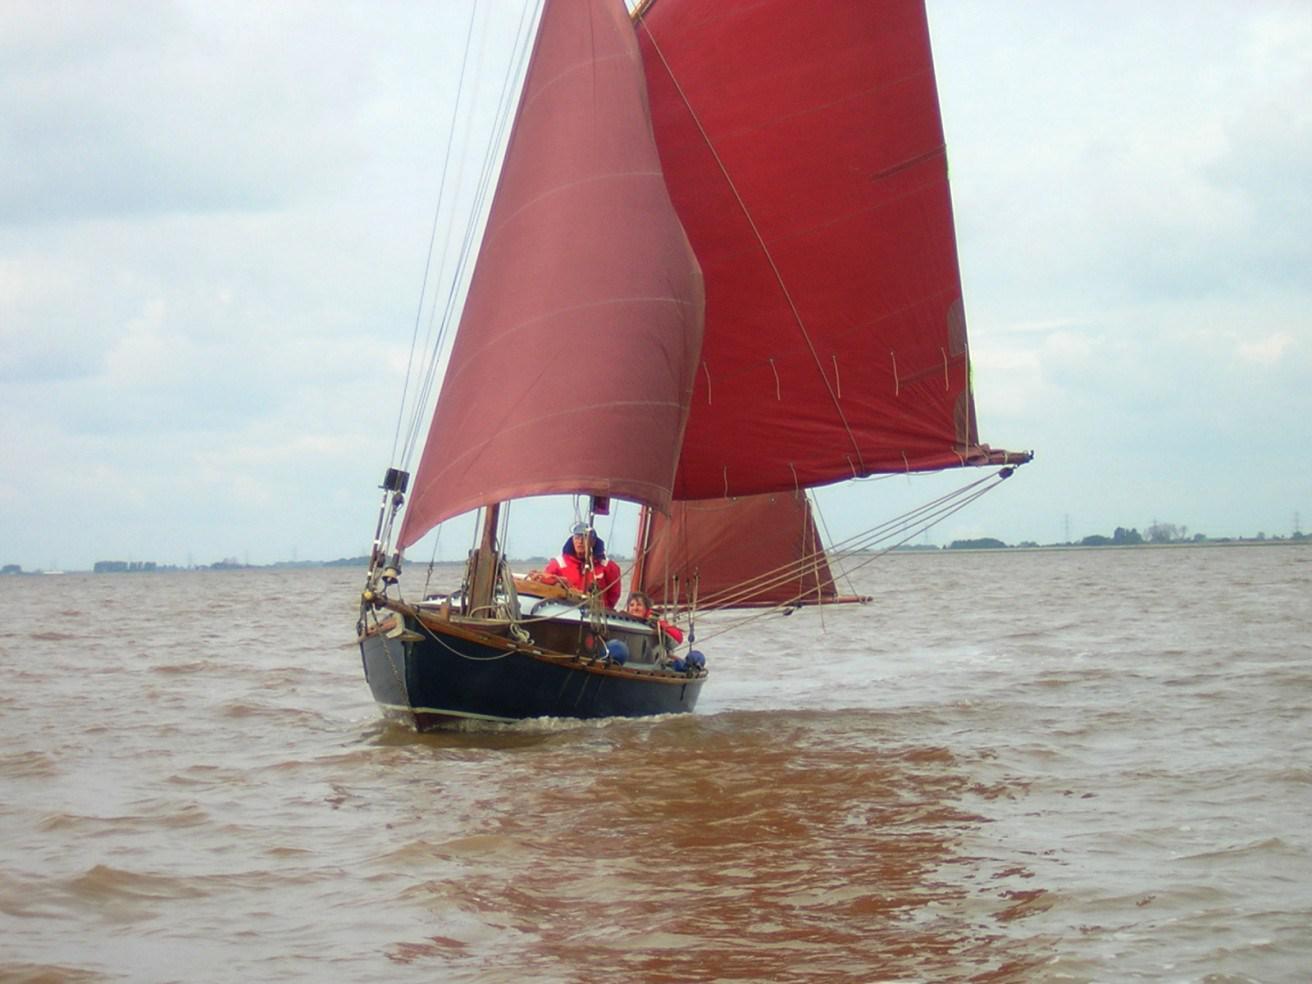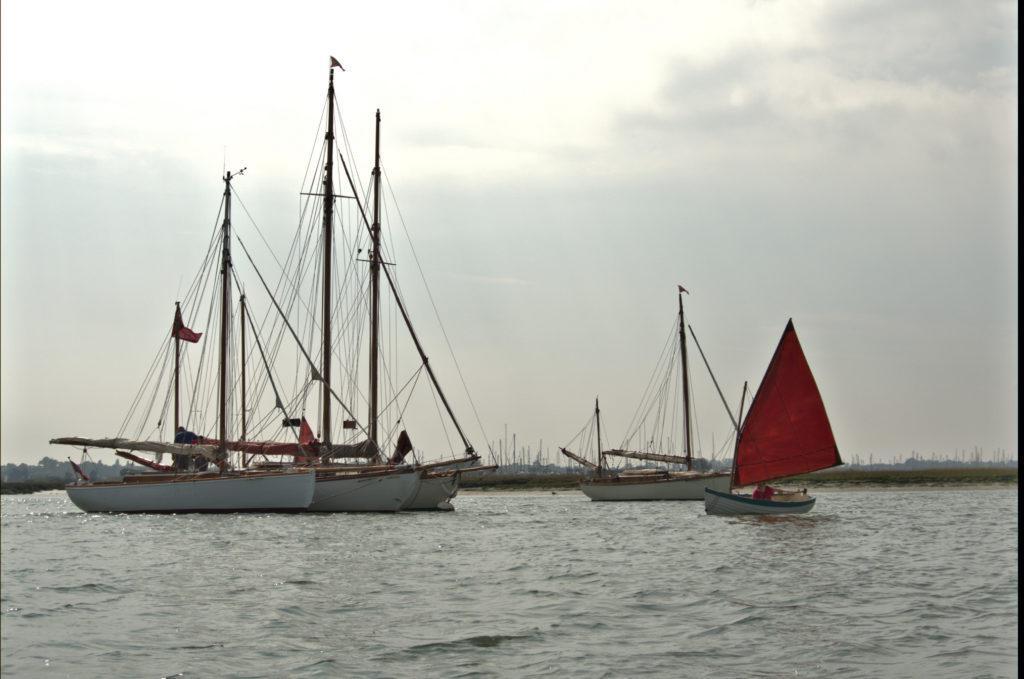The first image is the image on the left, the second image is the image on the right. Examine the images to the left and right. Is the description "There are three white sails in the image on the left." accurate? Answer yes or no. No. The first image is the image on the left, the second image is the image on the right. Assess this claim about the two images: "One of the images contains at least one sailboat with no raised sails.". Correct or not? Answer yes or no. Yes. 